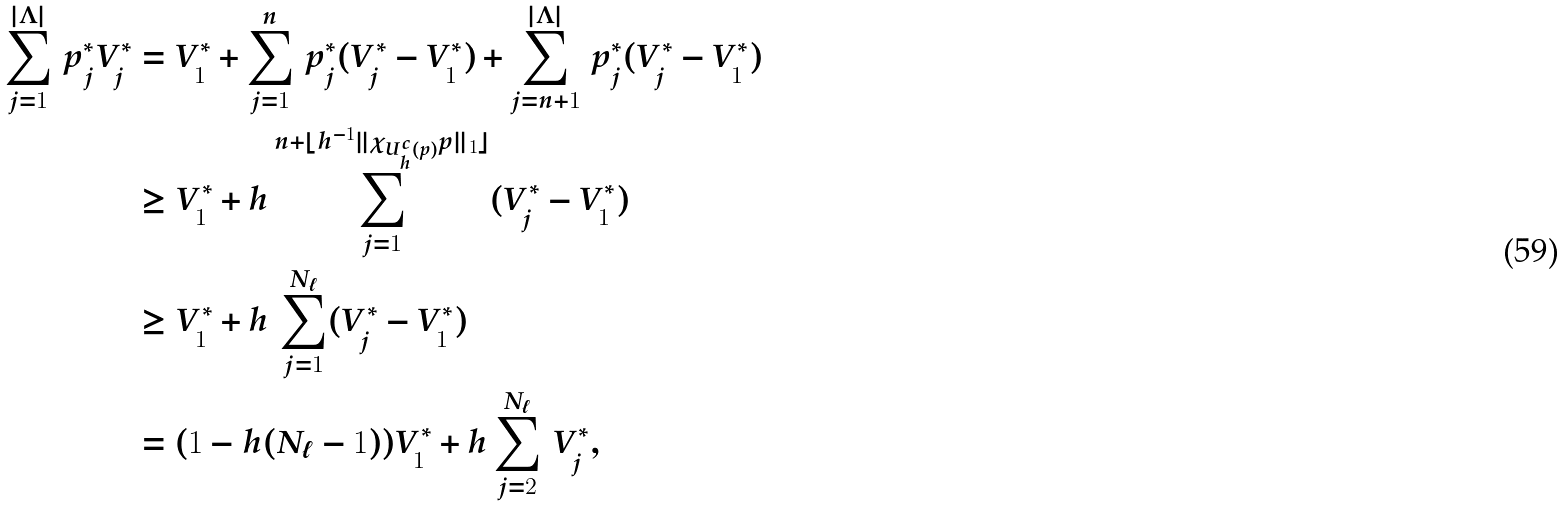<formula> <loc_0><loc_0><loc_500><loc_500>\sum _ { j = 1 } ^ { | \Lambda | } \, p ^ { * } _ { j } V ^ { * } _ { j } & = V _ { 1 } ^ { * } + \sum _ { j = 1 } ^ { n } \, p ^ { * } _ { j } ( V ^ { * } _ { j } - V _ { 1 } ^ { * } ) + \sum _ { j = n + 1 } ^ { | \Lambda | } \, p ^ { * } _ { j } ( V ^ { * } _ { j } - V _ { 1 } ^ { * } ) \\ & \geq V _ { 1 } ^ { * } + h \sum _ { j = 1 } ^ { n + \lfloor h ^ { - 1 } \| \chi _ { U ^ { c } _ { h } ( p ) } p \| _ { 1 } \rfloor } ( V ^ { * } _ { j } - V _ { 1 } ^ { * } ) \\ & \geq V _ { 1 } ^ { * } + h \, \sum _ { j = 1 } ^ { N _ { \ell } } ( V ^ { * } _ { j } - V _ { 1 } ^ { * } ) \\ & = ( 1 - h ( N _ { \ell } - 1 ) ) V _ { 1 } ^ { * } + h \sum _ { j = 2 } ^ { N _ { \ell } } \, V ^ { * } _ { j } ,</formula> 